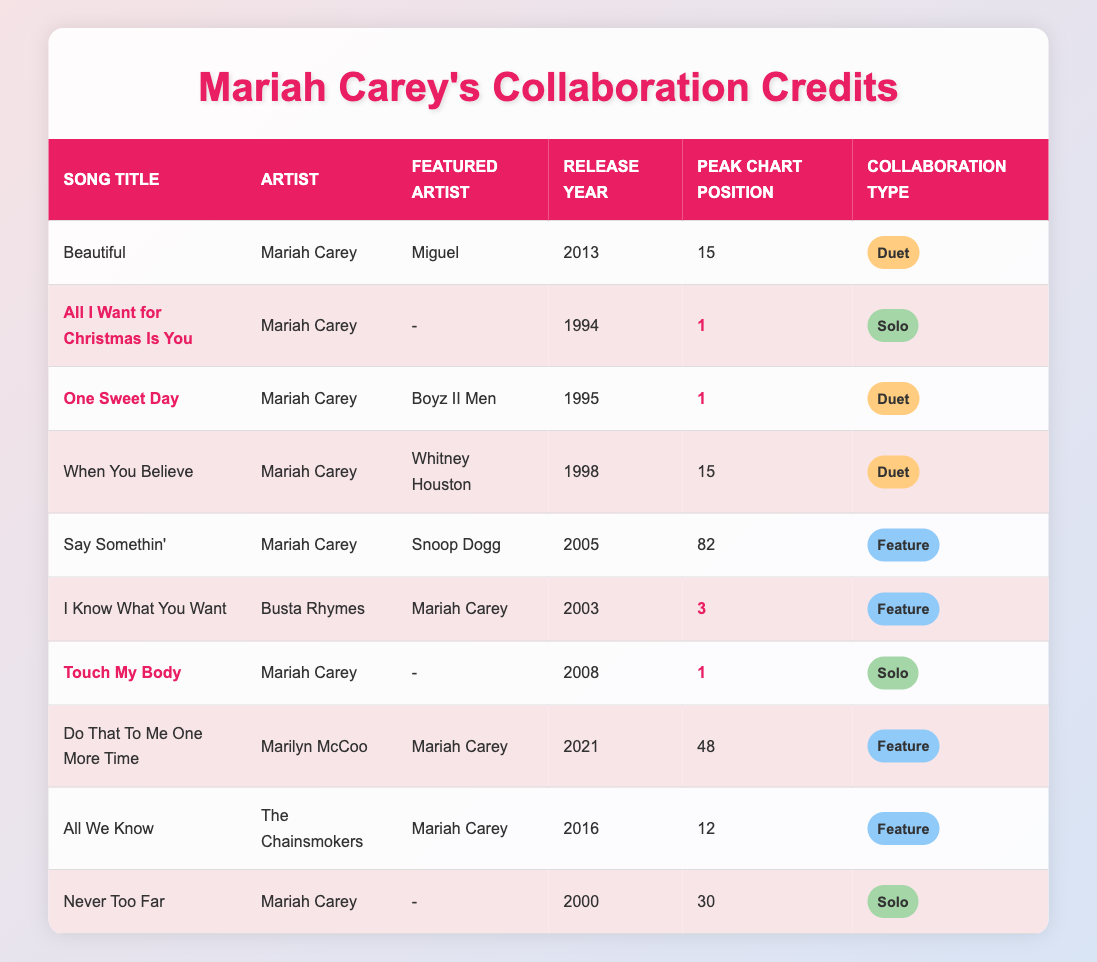What is the highest peak chart position achieved by a Mariah Carey song listed in the table? Reviewing the table, "All I Want for Christmas Is You," "One Sweet Day," and "Touch My Body" each have a peak chart position of 1, which is the highest among the songs.
Answer: 1 How many songs feature collaborations with other artists? In the table, the songs "Beautiful," "One Sweet Day," "When You Believe," "Say Somethin'," "I Know What You Want," "Do That To Me One More Time," and "All We Know" feature collaborations, which totals 7 songs.
Answer: 7 What year was "When You Believe" released? The table indicates that "When You Believe" was released in 1998 under the artist Mariah Carey featuring Whitney Houston.
Answer: 1998 Which song has the most recent release year? Scanning the table, "Do That To Me One More Time" released in 2021 is the most recent song compared to others.
Answer: 2021 Is "All I Want for Christmas Is You" a solo or collaborative work? According to the table, this song is marked as a "Solo," indicating that it doesn't feature any collaborations.
Answer: Solo How many duet collaborations does Mariah Carey have in the table? The table shows collaborations categorized as "Duet" for "Beautiful," "One Sweet Day," and "When You Believe," which means Mariah Carey has 3 duet collaborations.
Answer: 3 Which song, featuring Mariah Carey, peaked the highest on the chart as a featured artist? The table shows that "I Know What You Want" featuring Busta Rhymes reached a peak position of 3, which is the highest for collaborations where she was a featured artist.
Answer: 3 What percentage of the songs listed are classified as solo works? Among the 10 songs listed, 4 are classified as "Solo." Calculating the percentage: (4/10) * 100 = 40%.
Answer: 40% Which collaboration type has the highest number of songs associated in the table? By examining the collaboration types, "Feature" appears in 4 songs, while "Duet" appears in 3 songs and "Solo" in 3 songs, making "Feature" the most common type.
Answer: Feature Identify a song that features Snoop Dogg and state its chart position. In the table, "Say Somethin'" features Snoop Dogg as a featured artist, and it peaked at position 82 on the chart.
Answer: 82 